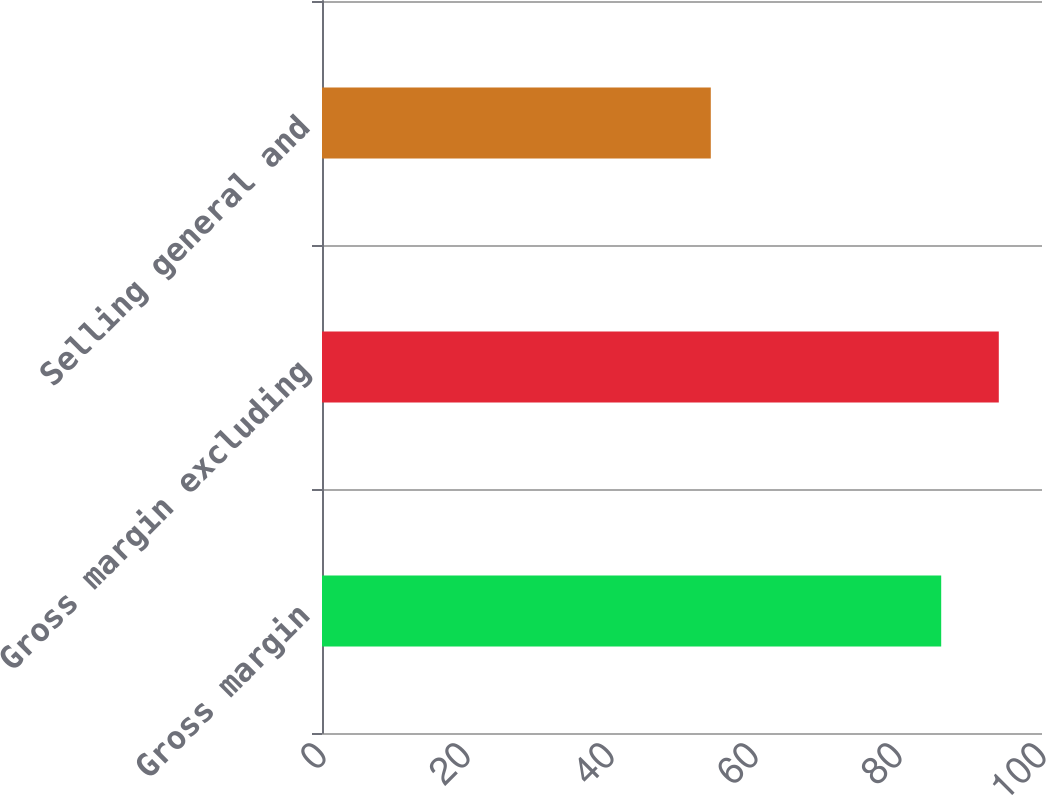<chart> <loc_0><loc_0><loc_500><loc_500><bar_chart><fcel>Gross margin<fcel>Gross margin excluding<fcel>Selling general and<nl><fcel>86<fcel>94<fcel>54<nl></chart> 